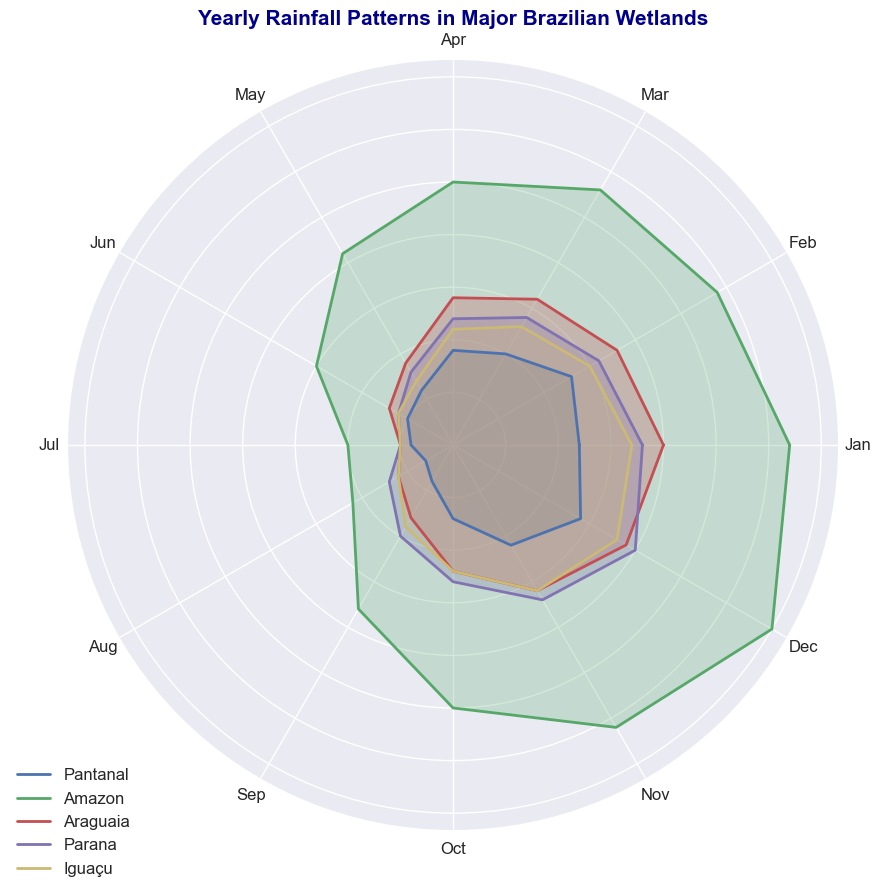Which wetland receives the most rainfall in July? To determine which wetland receives the most rainfall in July, look for the point on the July axis that is farthest from the center. Amazon has the highest value for July.
Answer: Amazon Which wetlands have lower rainfall in June compared to May? Compare the distances from the center for May and June for each wetland. If the point for June is closer to the center than that for May, the wetland has lower rainfall in June. Pantanal, Araguaia, Parana, and Iguaçu have lower values in June compared to May.
Answer: Pantanal, Araguaia, Parana, Iguaçu What is the average rainfall in December for Pantanal, Araguaia, and Iguaçu? Add the December values for Pantanal (140), Araguaia (190), and Iguaçu (180), then divide by the number of wetlands (3). The total is 140 + 190 + 180 = 510, and the average is 510/3 = 170.
Answer: 170 Rank the wetlands based on their rainfall in March from highest to lowest. Compare the values for March for each wetland. Amazon has 280, Araguaia has 160, Parana has 140, Pantanal has 100, and Iguaçu has 130. The ranking from highest to lowest is Amazon, Araguaia, Parana, Iguaçu, and Pantanal.
Answer: Amazon, Araguaia, Parana, Iguaçu, Pantanal Which wetland has the most consistent rainfall throughout the year? To determine the most consistent rainfall, look for the wetland whose chart line forms the most regular shape, meaning the distances from the center are the most similar. Iguaçu appears to have a relatively uniform pattern compared to the others.
Answer: Iguaçu What is the difference in rainfall between February and October for the Parana wetland? Subtract the October value from the February value for Parana. February has 160 and October has 130, so the difference is 160 - 130 = 30.
Answer: 30 Which month sees the highest rainfall in the Amazon wetland? Look for the month where the Amazon line is farthest from the center. The highest point appears to be in December with 350.
Answer: December 